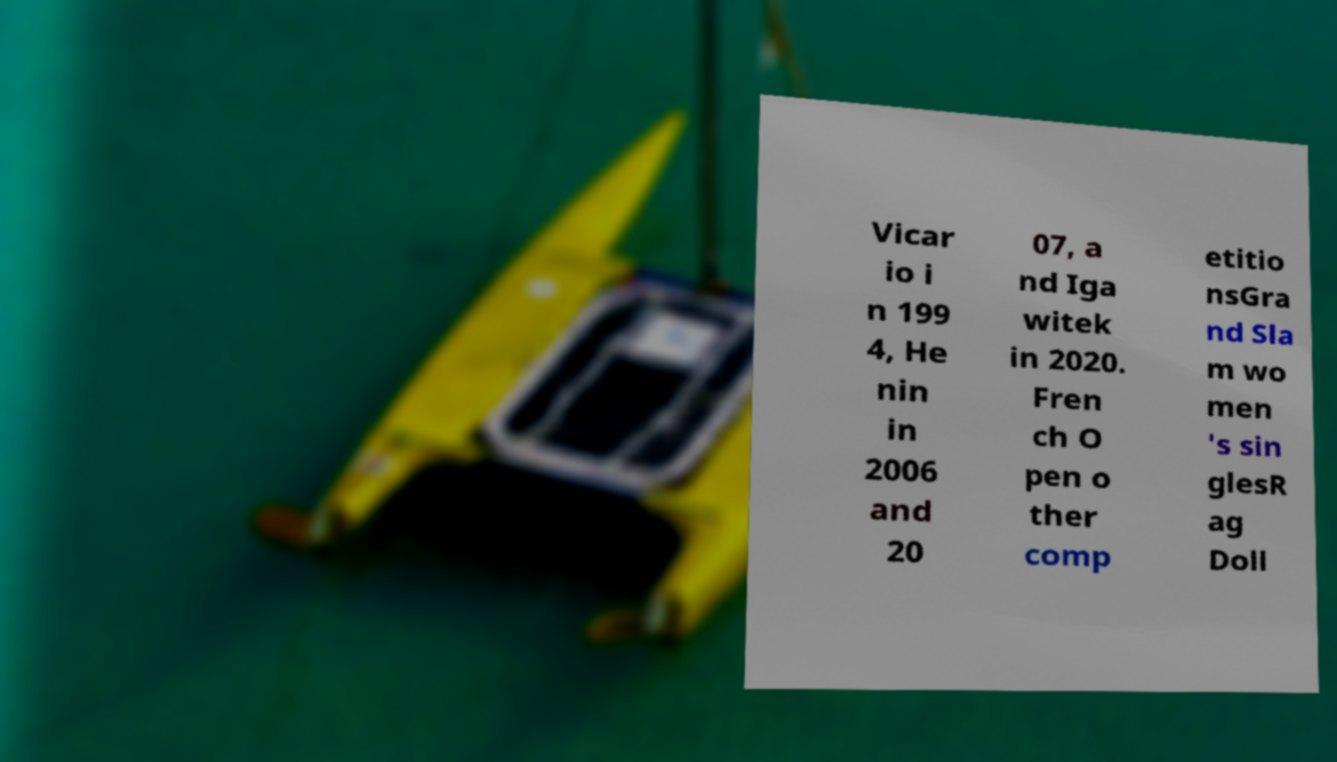Please identify and transcribe the text found in this image. Vicar io i n 199 4, He nin in 2006 and 20 07, a nd Iga witek in 2020. Fren ch O pen o ther comp etitio nsGra nd Sla m wo men 's sin glesR ag Doll 